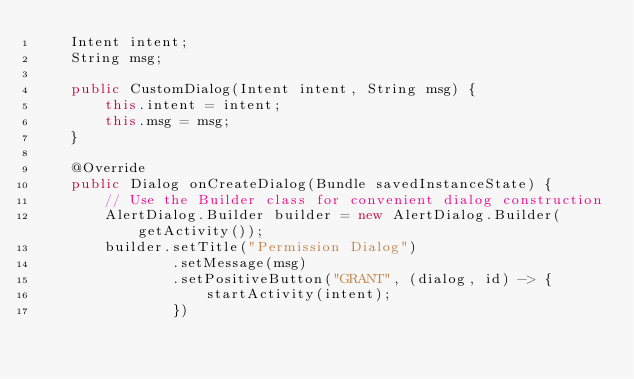Convert code to text. <code><loc_0><loc_0><loc_500><loc_500><_Java_>    Intent intent;
    String msg;

    public CustomDialog(Intent intent, String msg) {
        this.intent = intent;
        this.msg = msg;
    }

    @Override
    public Dialog onCreateDialog(Bundle savedInstanceState) {
        // Use the Builder class for convenient dialog construction
        AlertDialog.Builder builder = new AlertDialog.Builder(getActivity());
        builder.setTitle("Permission Dialog")
                .setMessage(msg)
                .setPositiveButton("GRANT", (dialog, id) -> {
                    startActivity(intent);
                })</code> 